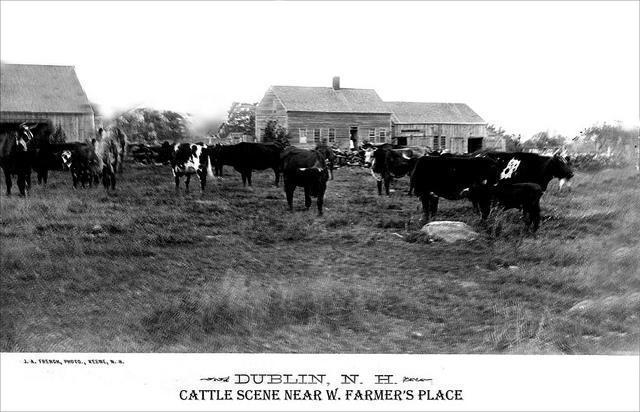How many cows are visible?
Give a very brief answer. 2. How many wheels does the suitcase have?
Give a very brief answer. 0. 